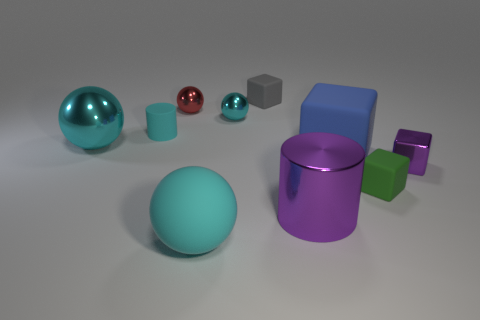Subtract all large blue blocks. How many blocks are left? 3 Subtract all cubes. How many objects are left? 6 Subtract all cyan cylinders. How many cylinders are left? 1 Subtract 1 red balls. How many objects are left? 9 Subtract 4 blocks. How many blocks are left? 0 Subtract all green balls. Subtract all green cubes. How many balls are left? 4 Subtract all red blocks. How many red spheres are left? 1 Subtract all large cyan shiny spheres. Subtract all big matte blocks. How many objects are left? 8 Add 3 red balls. How many red balls are left? 4 Add 6 green matte blocks. How many green matte blocks exist? 7 